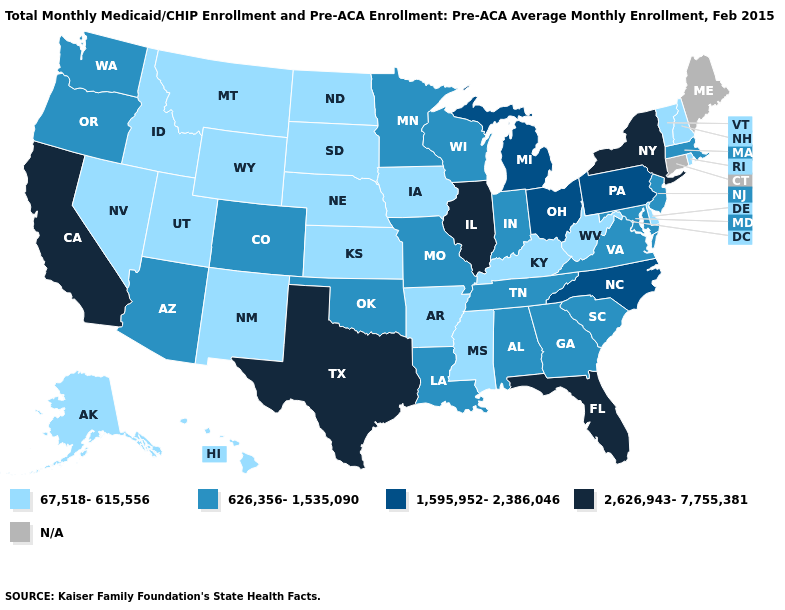What is the highest value in the USA?
Give a very brief answer. 2,626,943-7,755,381. What is the value of Pennsylvania?
Concise answer only. 1,595,952-2,386,046. Name the states that have a value in the range 1,595,952-2,386,046?
Quick response, please. Michigan, North Carolina, Ohio, Pennsylvania. Name the states that have a value in the range 1,595,952-2,386,046?
Give a very brief answer. Michigan, North Carolina, Ohio, Pennsylvania. What is the highest value in the USA?
Short answer required. 2,626,943-7,755,381. What is the value of Oregon?
Quick response, please. 626,356-1,535,090. What is the value of Connecticut?
Concise answer only. N/A. Does Illinois have the highest value in the MidWest?
Answer briefly. Yes. Which states have the lowest value in the MidWest?
Write a very short answer. Iowa, Kansas, Nebraska, North Dakota, South Dakota. Name the states that have a value in the range 67,518-615,556?
Answer briefly. Alaska, Arkansas, Delaware, Hawaii, Idaho, Iowa, Kansas, Kentucky, Mississippi, Montana, Nebraska, Nevada, New Hampshire, New Mexico, North Dakota, Rhode Island, South Dakota, Utah, Vermont, West Virginia, Wyoming. Name the states that have a value in the range N/A?
Be succinct. Connecticut, Maine. Does Texas have the lowest value in the USA?
Concise answer only. No. 